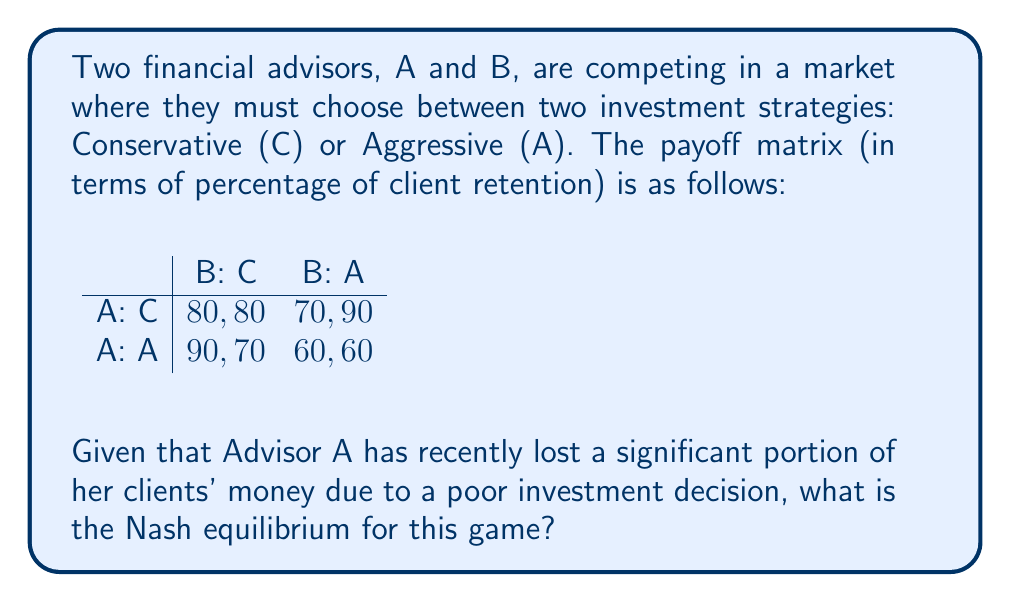Can you answer this question? To find the Nash equilibrium, we need to analyze each advisor's best response to the other's strategy:

1. For Advisor A:
   - If B chooses C: A's best response is A (90 > 80)
   - If B chooses A: A's best response is C (70 > 60)

2. For Advisor B:
   - If A chooses C: B's best response is A (90 > 80)
   - If A chooses A: B's best response is C (70 > 60)

We can see that there is no pure strategy Nash equilibrium, as there's no cell where both advisors are playing their best responses simultaneously.

To find the mixed strategy Nash equilibrium, let's define:
- $p$ = probability of A playing C
- $q$ = probability of B playing C

For A to be indifferent between C and A:
$80q + 70(1-q) = 90q + 60(1-q)$
$80q + 70 - 70q = 90q + 60 - 60q$
$10q = 10$
$q = 1/2$

For B to be indifferent between C and A:
$80p + 90(1-p) = 70p + 60(1-p)$
$80p + 90 - 90p = 70p + 60 - 60p$
$-10p = -30$
$p = 3/4$

Therefore, the mixed strategy Nash equilibrium is:
- A plays C with probability 3/4 and A with probability 1/4
- B plays C with probability 1/2 and A with probability 1/2
Answer: The Nash equilibrium is a mixed strategy where Advisor A plays Conservative with probability 3/4 and Aggressive with probability 1/4, while Advisor B plays Conservative with probability 1/2 and Aggressive with probability 1/2. 